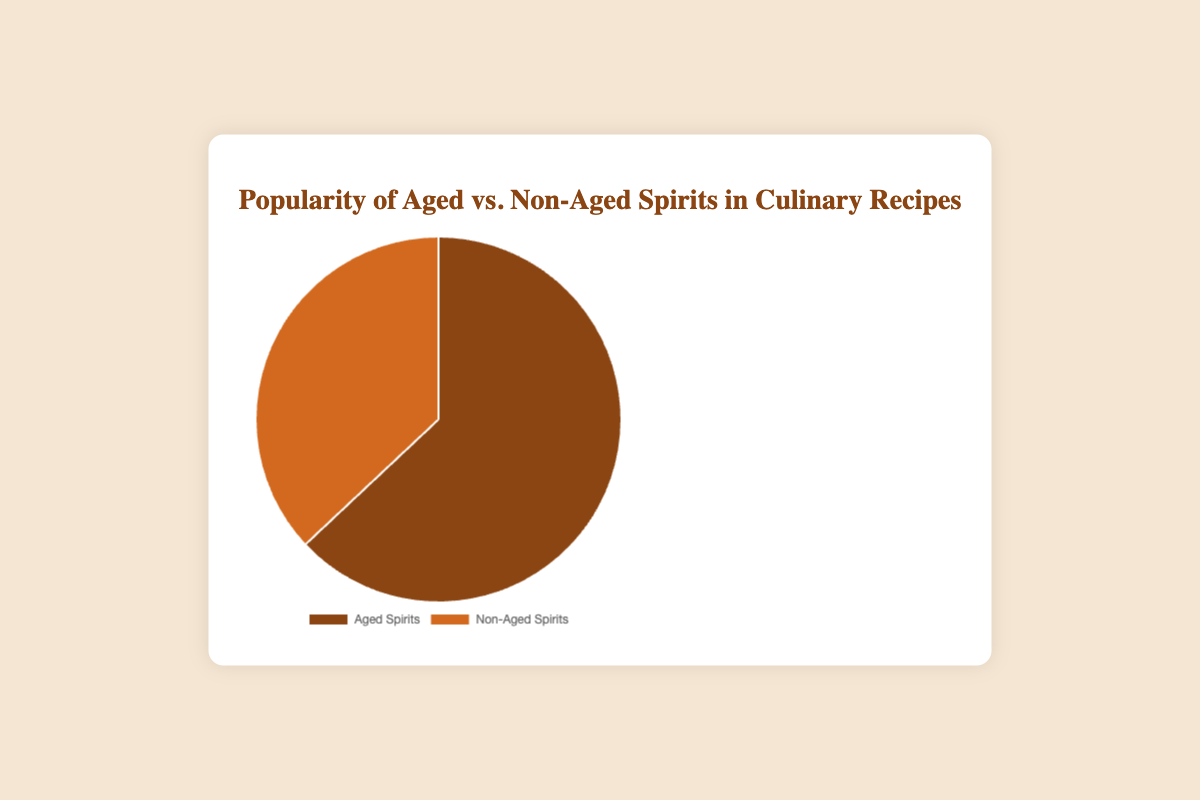What is the popularity percentage of aged spirits in culinary recipes? The pie chart shows that aged spirits have a segment labeled with a percentage that represents their popularity.
Answer: 63% What is the popularity percentage of non-aged spirits in culinary recipes? The pie chart shows that non-aged spirits have a segment labeled with a percentage that represents their popularity.
Answer: 37% Which type of spirit is more popular in culinary recipes? By comparing the sizes of the segments on the pie chart, it's clear that the segment for aged spirits is larger than the segment for non-aged spirits.
Answer: Aged Spirits By how much is the popularity of aged spirits greater than non-aged spirits? Subtract the percentage popularity of non-aged spirits from the percentage popularity of aged spirits: 63% - 37%.
Answer: 26% What is the sum of the popularity percentages for both types of spirits? Add the popularity percentages of aged and non-aged spirits: 63% + 37%.
Answer: 100% What color represents aged spirits in the chart? By looking at the chart legend, the color corresponding to aged spirits is clearly shown.
Answer: Brown What color represents non-aged spirits in the chart? By looking at the chart legend, the color corresponding to non-aged spirits is clearly shown.
Answer: Orange If you combine the popularity of aged and non-aged spirits, what fraction of the whole pie does it represent? The pie chart represents the total usage of spirits, so combining the popularity of aged and non-aged spirits equals the whole pie or 1 (100%).
Answer: 1 (100%) What insight can we derive from the fact that the aged spirits segment is larger than the non-aged spirits segment in the pie chart? The larger segment for aged spirits indicates that they are more commonly used in culinary recipes compared to non-aged spirits.
Answer: Aged spirits are more commonly used What is the ratio of aged spirits to non-aged spirits usage in culinary recipes? Divide the popularity percentage of aged spirits by the percentage of non-aged spirits: 63 / 37.
Answer: 63:37 or approximately 1.7:1 